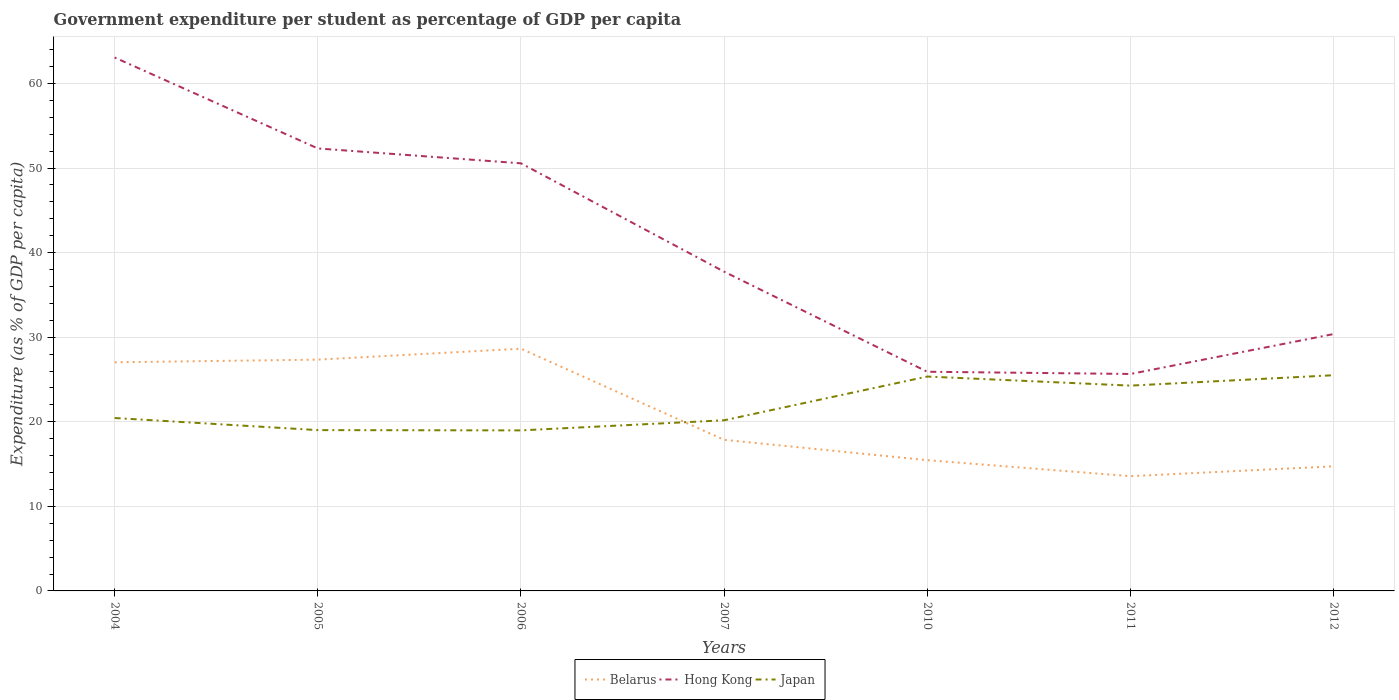Is the number of lines equal to the number of legend labels?
Your response must be concise. Yes. Across all years, what is the maximum percentage of expenditure per student in Japan?
Provide a succinct answer. 18.98. What is the total percentage of expenditure per student in Belarus in the graph?
Offer a terse response. -1.29. What is the difference between the highest and the second highest percentage of expenditure per student in Hong Kong?
Offer a terse response. 37.42. What is the difference between the highest and the lowest percentage of expenditure per student in Japan?
Provide a short and direct response. 3. How many lines are there?
Your response must be concise. 3. Are the values on the major ticks of Y-axis written in scientific E-notation?
Ensure brevity in your answer.  No. Does the graph contain grids?
Keep it short and to the point. Yes. Where does the legend appear in the graph?
Provide a succinct answer. Bottom center. How many legend labels are there?
Ensure brevity in your answer.  3. What is the title of the graph?
Offer a very short reply. Government expenditure per student as percentage of GDP per capita. Does "World" appear as one of the legend labels in the graph?
Offer a very short reply. No. What is the label or title of the X-axis?
Your answer should be compact. Years. What is the label or title of the Y-axis?
Ensure brevity in your answer.  Expenditure (as % of GDP per capita). What is the Expenditure (as % of GDP per capita) of Belarus in 2004?
Your answer should be very brief. 27.04. What is the Expenditure (as % of GDP per capita) in Hong Kong in 2004?
Offer a very short reply. 63.07. What is the Expenditure (as % of GDP per capita) in Japan in 2004?
Ensure brevity in your answer.  20.45. What is the Expenditure (as % of GDP per capita) of Belarus in 2005?
Offer a very short reply. 27.35. What is the Expenditure (as % of GDP per capita) in Hong Kong in 2005?
Ensure brevity in your answer.  52.32. What is the Expenditure (as % of GDP per capita) of Japan in 2005?
Offer a terse response. 19.02. What is the Expenditure (as % of GDP per capita) of Belarus in 2006?
Your answer should be compact. 28.64. What is the Expenditure (as % of GDP per capita) of Hong Kong in 2006?
Your response must be concise. 50.56. What is the Expenditure (as % of GDP per capita) of Japan in 2006?
Provide a succinct answer. 18.98. What is the Expenditure (as % of GDP per capita) in Belarus in 2007?
Give a very brief answer. 17.87. What is the Expenditure (as % of GDP per capita) of Hong Kong in 2007?
Give a very brief answer. 37.75. What is the Expenditure (as % of GDP per capita) in Japan in 2007?
Your response must be concise. 20.18. What is the Expenditure (as % of GDP per capita) in Belarus in 2010?
Provide a succinct answer. 15.46. What is the Expenditure (as % of GDP per capita) in Hong Kong in 2010?
Ensure brevity in your answer.  25.92. What is the Expenditure (as % of GDP per capita) in Japan in 2010?
Make the answer very short. 25.35. What is the Expenditure (as % of GDP per capita) of Belarus in 2011?
Offer a very short reply. 13.57. What is the Expenditure (as % of GDP per capita) of Hong Kong in 2011?
Give a very brief answer. 25.65. What is the Expenditure (as % of GDP per capita) in Japan in 2011?
Offer a very short reply. 24.28. What is the Expenditure (as % of GDP per capita) in Belarus in 2012?
Your answer should be very brief. 14.73. What is the Expenditure (as % of GDP per capita) in Hong Kong in 2012?
Your answer should be very brief. 30.37. What is the Expenditure (as % of GDP per capita) of Japan in 2012?
Give a very brief answer. 25.5. Across all years, what is the maximum Expenditure (as % of GDP per capita) of Belarus?
Provide a short and direct response. 28.64. Across all years, what is the maximum Expenditure (as % of GDP per capita) in Hong Kong?
Your answer should be very brief. 63.07. Across all years, what is the maximum Expenditure (as % of GDP per capita) in Japan?
Give a very brief answer. 25.5. Across all years, what is the minimum Expenditure (as % of GDP per capita) of Belarus?
Give a very brief answer. 13.57. Across all years, what is the minimum Expenditure (as % of GDP per capita) of Hong Kong?
Offer a very short reply. 25.65. Across all years, what is the minimum Expenditure (as % of GDP per capita) in Japan?
Keep it short and to the point. 18.98. What is the total Expenditure (as % of GDP per capita) of Belarus in the graph?
Your answer should be compact. 144.66. What is the total Expenditure (as % of GDP per capita) in Hong Kong in the graph?
Your answer should be very brief. 285.65. What is the total Expenditure (as % of GDP per capita) of Japan in the graph?
Offer a very short reply. 153.75. What is the difference between the Expenditure (as % of GDP per capita) in Belarus in 2004 and that in 2005?
Make the answer very short. -0.31. What is the difference between the Expenditure (as % of GDP per capita) of Hong Kong in 2004 and that in 2005?
Offer a terse response. 10.75. What is the difference between the Expenditure (as % of GDP per capita) of Japan in 2004 and that in 2005?
Ensure brevity in your answer.  1.43. What is the difference between the Expenditure (as % of GDP per capita) of Belarus in 2004 and that in 2006?
Offer a very short reply. -1.61. What is the difference between the Expenditure (as % of GDP per capita) of Hong Kong in 2004 and that in 2006?
Your answer should be very brief. 12.51. What is the difference between the Expenditure (as % of GDP per capita) in Japan in 2004 and that in 2006?
Provide a short and direct response. 1.47. What is the difference between the Expenditure (as % of GDP per capita) in Belarus in 2004 and that in 2007?
Give a very brief answer. 9.17. What is the difference between the Expenditure (as % of GDP per capita) in Hong Kong in 2004 and that in 2007?
Make the answer very short. 25.32. What is the difference between the Expenditure (as % of GDP per capita) in Japan in 2004 and that in 2007?
Offer a terse response. 0.27. What is the difference between the Expenditure (as % of GDP per capita) of Belarus in 2004 and that in 2010?
Your answer should be compact. 11.57. What is the difference between the Expenditure (as % of GDP per capita) in Hong Kong in 2004 and that in 2010?
Offer a terse response. 37.16. What is the difference between the Expenditure (as % of GDP per capita) of Japan in 2004 and that in 2010?
Provide a succinct answer. -4.9. What is the difference between the Expenditure (as % of GDP per capita) of Belarus in 2004 and that in 2011?
Offer a very short reply. 13.47. What is the difference between the Expenditure (as % of GDP per capita) of Hong Kong in 2004 and that in 2011?
Your answer should be compact. 37.42. What is the difference between the Expenditure (as % of GDP per capita) of Japan in 2004 and that in 2011?
Offer a very short reply. -3.83. What is the difference between the Expenditure (as % of GDP per capita) of Belarus in 2004 and that in 2012?
Provide a short and direct response. 12.3. What is the difference between the Expenditure (as % of GDP per capita) in Hong Kong in 2004 and that in 2012?
Your answer should be compact. 32.7. What is the difference between the Expenditure (as % of GDP per capita) of Japan in 2004 and that in 2012?
Ensure brevity in your answer.  -5.06. What is the difference between the Expenditure (as % of GDP per capita) in Belarus in 2005 and that in 2006?
Make the answer very short. -1.29. What is the difference between the Expenditure (as % of GDP per capita) in Hong Kong in 2005 and that in 2006?
Ensure brevity in your answer.  1.76. What is the difference between the Expenditure (as % of GDP per capita) in Japan in 2005 and that in 2006?
Give a very brief answer. 0.03. What is the difference between the Expenditure (as % of GDP per capita) in Belarus in 2005 and that in 2007?
Your answer should be very brief. 9.48. What is the difference between the Expenditure (as % of GDP per capita) in Hong Kong in 2005 and that in 2007?
Give a very brief answer. 14.57. What is the difference between the Expenditure (as % of GDP per capita) of Japan in 2005 and that in 2007?
Keep it short and to the point. -1.16. What is the difference between the Expenditure (as % of GDP per capita) in Belarus in 2005 and that in 2010?
Your answer should be very brief. 11.89. What is the difference between the Expenditure (as % of GDP per capita) in Hong Kong in 2005 and that in 2010?
Ensure brevity in your answer.  26.4. What is the difference between the Expenditure (as % of GDP per capita) of Japan in 2005 and that in 2010?
Your response must be concise. -6.34. What is the difference between the Expenditure (as % of GDP per capita) of Belarus in 2005 and that in 2011?
Your answer should be compact. 13.78. What is the difference between the Expenditure (as % of GDP per capita) of Hong Kong in 2005 and that in 2011?
Your response must be concise. 26.67. What is the difference between the Expenditure (as % of GDP per capita) in Japan in 2005 and that in 2011?
Offer a very short reply. -5.26. What is the difference between the Expenditure (as % of GDP per capita) in Belarus in 2005 and that in 2012?
Provide a succinct answer. 12.62. What is the difference between the Expenditure (as % of GDP per capita) in Hong Kong in 2005 and that in 2012?
Make the answer very short. 21.95. What is the difference between the Expenditure (as % of GDP per capita) in Japan in 2005 and that in 2012?
Ensure brevity in your answer.  -6.49. What is the difference between the Expenditure (as % of GDP per capita) of Belarus in 2006 and that in 2007?
Ensure brevity in your answer.  10.78. What is the difference between the Expenditure (as % of GDP per capita) in Hong Kong in 2006 and that in 2007?
Make the answer very short. 12.81. What is the difference between the Expenditure (as % of GDP per capita) of Japan in 2006 and that in 2007?
Provide a short and direct response. -1.19. What is the difference between the Expenditure (as % of GDP per capita) in Belarus in 2006 and that in 2010?
Offer a terse response. 13.18. What is the difference between the Expenditure (as % of GDP per capita) of Hong Kong in 2006 and that in 2010?
Keep it short and to the point. 24.65. What is the difference between the Expenditure (as % of GDP per capita) in Japan in 2006 and that in 2010?
Make the answer very short. -6.37. What is the difference between the Expenditure (as % of GDP per capita) of Belarus in 2006 and that in 2011?
Make the answer very short. 15.07. What is the difference between the Expenditure (as % of GDP per capita) in Hong Kong in 2006 and that in 2011?
Provide a succinct answer. 24.91. What is the difference between the Expenditure (as % of GDP per capita) of Japan in 2006 and that in 2011?
Offer a very short reply. -5.29. What is the difference between the Expenditure (as % of GDP per capita) in Belarus in 2006 and that in 2012?
Your answer should be very brief. 13.91. What is the difference between the Expenditure (as % of GDP per capita) of Hong Kong in 2006 and that in 2012?
Keep it short and to the point. 20.19. What is the difference between the Expenditure (as % of GDP per capita) of Japan in 2006 and that in 2012?
Give a very brief answer. -6.52. What is the difference between the Expenditure (as % of GDP per capita) of Belarus in 2007 and that in 2010?
Your response must be concise. 2.41. What is the difference between the Expenditure (as % of GDP per capita) of Hong Kong in 2007 and that in 2010?
Your answer should be compact. 11.83. What is the difference between the Expenditure (as % of GDP per capita) in Japan in 2007 and that in 2010?
Ensure brevity in your answer.  -5.17. What is the difference between the Expenditure (as % of GDP per capita) of Belarus in 2007 and that in 2011?
Give a very brief answer. 4.3. What is the difference between the Expenditure (as % of GDP per capita) of Hong Kong in 2007 and that in 2011?
Offer a very short reply. 12.1. What is the difference between the Expenditure (as % of GDP per capita) of Japan in 2007 and that in 2011?
Your answer should be very brief. -4.1. What is the difference between the Expenditure (as % of GDP per capita) of Belarus in 2007 and that in 2012?
Offer a terse response. 3.13. What is the difference between the Expenditure (as % of GDP per capita) of Hong Kong in 2007 and that in 2012?
Offer a very short reply. 7.38. What is the difference between the Expenditure (as % of GDP per capita) in Japan in 2007 and that in 2012?
Provide a short and direct response. -5.33. What is the difference between the Expenditure (as % of GDP per capita) in Belarus in 2010 and that in 2011?
Provide a succinct answer. 1.89. What is the difference between the Expenditure (as % of GDP per capita) in Hong Kong in 2010 and that in 2011?
Keep it short and to the point. 0.26. What is the difference between the Expenditure (as % of GDP per capita) in Japan in 2010 and that in 2011?
Give a very brief answer. 1.07. What is the difference between the Expenditure (as % of GDP per capita) in Belarus in 2010 and that in 2012?
Provide a short and direct response. 0.73. What is the difference between the Expenditure (as % of GDP per capita) of Hong Kong in 2010 and that in 2012?
Your answer should be compact. -4.46. What is the difference between the Expenditure (as % of GDP per capita) in Japan in 2010 and that in 2012?
Your answer should be very brief. -0.15. What is the difference between the Expenditure (as % of GDP per capita) in Belarus in 2011 and that in 2012?
Provide a succinct answer. -1.16. What is the difference between the Expenditure (as % of GDP per capita) of Hong Kong in 2011 and that in 2012?
Offer a terse response. -4.72. What is the difference between the Expenditure (as % of GDP per capita) of Japan in 2011 and that in 2012?
Ensure brevity in your answer.  -1.23. What is the difference between the Expenditure (as % of GDP per capita) of Belarus in 2004 and the Expenditure (as % of GDP per capita) of Hong Kong in 2005?
Provide a succinct answer. -25.29. What is the difference between the Expenditure (as % of GDP per capita) of Belarus in 2004 and the Expenditure (as % of GDP per capita) of Japan in 2005?
Keep it short and to the point. 8.02. What is the difference between the Expenditure (as % of GDP per capita) in Hong Kong in 2004 and the Expenditure (as % of GDP per capita) in Japan in 2005?
Your answer should be very brief. 44.06. What is the difference between the Expenditure (as % of GDP per capita) in Belarus in 2004 and the Expenditure (as % of GDP per capita) in Hong Kong in 2006?
Your answer should be compact. -23.53. What is the difference between the Expenditure (as % of GDP per capita) in Belarus in 2004 and the Expenditure (as % of GDP per capita) in Japan in 2006?
Keep it short and to the point. 8.05. What is the difference between the Expenditure (as % of GDP per capita) in Hong Kong in 2004 and the Expenditure (as % of GDP per capita) in Japan in 2006?
Provide a succinct answer. 44.09. What is the difference between the Expenditure (as % of GDP per capita) in Belarus in 2004 and the Expenditure (as % of GDP per capita) in Hong Kong in 2007?
Your answer should be very brief. -10.72. What is the difference between the Expenditure (as % of GDP per capita) in Belarus in 2004 and the Expenditure (as % of GDP per capita) in Japan in 2007?
Ensure brevity in your answer.  6.86. What is the difference between the Expenditure (as % of GDP per capita) in Hong Kong in 2004 and the Expenditure (as % of GDP per capita) in Japan in 2007?
Your response must be concise. 42.9. What is the difference between the Expenditure (as % of GDP per capita) in Belarus in 2004 and the Expenditure (as % of GDP per capita) in Hong Kong in 2010?
Offer a terse response. 1.12. What is the difference between the Expenditure (as % of GDP per capita) of Belarus in 2004 and the Expenditure (as % of GDP per capita) of Japan in 2010?
Provide a succinct answer. 1.68. What is the difference between the Expenditure (as % of GDP per capita) of Hong Kong in 2004 and the Expenditure (as % of GDP per capita) of Japan in 2010?
Offer a terse response. 37.72. What is the difference between the Expenditure (as % of GDP per capita) in Belarus in 2004 and the Expenditure (as % of GDP per capita) in Hong Kong in 2011?
Offer a terse response. 1.38. What is the difference between the Expenditure (as % of GDP per capita) of Belarus in 2004 and the Expenditure (as % of GDP per capita) of Japan in 2011?
Keep it short and to the point. 2.76. What is the difference between the Expenditure (as % of GDP per capita) in Hong Kong in 2004 and the Expenditure (as % of GDP per capita) in Japan in 2011?
Ensure brevity in your answer.  38.8. What is the difference between the Expenditure (as % of GDP per capita) of Belarus in 2004 and the Expenditure (as % of GDP per capita) of Hong Kong in 2012?
Provide a short and direct response. -3.34. What is the difference between the Expenditure (as % of GDP per capita) of Belarus in 2004 and the Expenditure (as % of GDP per capita) of Japan in 2012?
Ensure brevity in your answer.  1.53. What is the difference between the Expenditure (as % of GDP per capita) of Hong Kong in 2004 and the Expenditure (as % of GDP per capita) of Japan in 2012?
Give a very brief answer. 37.57. What is the difference between the Expenditure (as % of GDP per capita) in Belarus in 2005 and the Expenditure (as % of GDP per capita) in Hong Kong in 2006?
Provide a succinct answer. -23.21. What is the difference between the Expenditure (as % of GDP per capita) of Belarus in 2005 and the Expenditure (as % of GDP per capita) of Japan in 2006?
Keep it short and to the point. 8.37. What is the difference between the Expenditure (as % of GDP per capita) of Hong Kong in 2005 and the Expenditure (as % of GDP per capita) of Japan in 2006?
Offer a very short reply. 33.34. What is the difference between the Expenditure (as % of GDP per capita) of Belarus in 2005 and the Expenditure (as % of GDP per capita) of Hong Kong in 2007?
Your answer should be compact. -10.4. What is the difference between the Expenditure (as % of GDP per capita) in Belarus in 2005 and the Expenditure (as % of GDP per capita) in Japan in 2007?
Offer a terse response. 7.17. What is the difference between the Expenditure (as % of GDP per capita) of Hong Kong in 2005 and the Expenditure (as % of GDP per capita) of Japan in 2007?
Your answer should be compact. 32.15. What is the difference between the Expenditure (as % of GDP per capita) in Belarus in 2005 and the Expenditure (as % of GDP per capita) in Hong Kong in 2010?
Provide a short and direct response. 1.43. What is the difference between the Expenditure (as % of GDP per capita) of Belarus in 2005 and the Expenditure (as % of GDP per capita) of Japan in 2010?
Offer a terse response. 2. What is the difference between the Expenditure (as % of GDP per capita) in Hong Kong in 2005 and the Expenditure (as % of GDP per capita) in Japan in 2010?
Give a very brief answer. 26.97. What is the difference between the Expenditure (as % of GDP per capita) in Belarus in 2005 and the Expenditure (as % of GDP per capita) in Hong Kong in 2011?
Offer a terse response. 1.69. What is the difference between the Expenditure (as % of GDP per capita) in Belarus in 2005 and the Expenditure (as % of GDP per capita) in Japan in 2011?
Provide a succinct answer. 3.07. What is the difference between the Expenditure (as % of GDP per capita) of Hong Kong in 2005 and the Expenditure (as % of GDP per capita) of Japan in 2011?
Keep it short and to the point. 28.05. What is the difference between the Expenditure (as % of GDP per capita) of Belarus in 2005 and the Expenditure (as % of GDP per capita) of Hong Kong in 2012?
Your answer should be compact. -3.02. What is the difference between the Expenditure (as % of GDP per capita) of Belarus in 2005 and the Expenditure (as % of GDP per capita) of Japan in 2012?
Your answer should be very brief. 1.84. What is the difference between the Expenditure (as % of GDP per capita) in Hong Kong in 2005 and the Expenditure (as % of GDP per capita) in Japan in 2012?
Offer a terse response. 26.82. What is the difference between the Expenditure (as % of GDP per capita) of Belarus in 2006 and the Expenditure (as % of GDP per capita) of Hong Kong in 2007?
Give a very brief answer. -9.11. What is the difference between the Expenditure (as % of GDP per capita) of Belarus in 2006 and the Expenditure (as % of GDP per capita) of Japan in 2007?
Ensure brevity in your answer.  8.47. What is the difference between the Expenditure (as % of GDP per capita) in Hong Kong in 2006 and the Expenditure (as % of GDP per capita) in Japan in 2007?
Give a very brief answer. 30.39. What is the difference between the Expenditure (as % of GDP per capita) of Belarus in 2006 and the Expenditure (as % of GDP per capita) of Hong Kong in 2010?
Offer a very short reply. 2.73. What is the difference between the Expenditure (as % of GDP per capita) in Belarus in 2006 and the Expenditure (as % of GDP per capita) in Japan in 2010?
Offer a terse response. 3.29. What is the difference between the Expenditure (as % of GDP per capita) of Hong Kong in 2006 and the Expenditure (as % of GDP per capita) of Japan in 2010?
Make the answer very short. 25.21. What is the difference between the Expenditure (as % of GDP per capita) in Belarus in 2006 and the Expenditure (as % of GDP per capita) in Hong Kong in 2011?
Provide a succinct answer. 2.99. What is the difference between the Expenditure (as % of GDP per capita) in Belarus in 2006 and the Expenditure (as % of GDP per capita) in Japan in 2011?
Offer a terse response. 4.37. What is the difference between the Expenditure (as % of GDP per capita) in Hong Kong in 2006 and the Expenditure (as % of GDP per capita) in Japan in 2011?
Ensure brevity in your answer.  26.29. What is the difference between the Expenditure (as % of GDP per capita) in Belarus in 2006 and the Expenditure (as % of GDP per capita) in Hong Kong in 2012?
Your answer should be compact. -1.73. What is the difference between the Expenditure (as % of GDP per capita) in Belarus in 2006 and the Expenditure (as % of GDP per capita) in Japan in 2012?
Provide a succinct answer. 3.14. What is the difference between the Expenditure (as % of GDP per capita) in Hong Kong in 2006 and the Expenditure (as % of GDP per capita) in Japan in 2012?
Ensure brevity in your answer.  25.06. What is the difference between the Expenditure (as % of GDP per capita) of Belarus in 2007 and the Expenditure (as % of GDP per capita) of Hong Kong in 2010?
Your answer should be very brief. -8.05. What is the difference between the Expenditure (as % of GDP per capita) in Belarus in 2007 and the Expenditure (as % of GDP per capita) in Japan in 2010?
Offer a very short reply. -7.48. What is the difference between the Expenditure (as % of GDP per capita) of Hong Kong in 2007 and the Expenditure (as % of GDP per capita) of Japan in 2010?
Ensure brevity in your answer.  12.4. What is the difference between the Expenditure (as % of GDP per capita) of Belarus in 2007 and the Expenditure (as % of GDP per capita) of Hong Kong in 2011?
Make the answer very short. -7.79. What is the difference between the Expenditure (as % of GDP per capita) in Belarus in 2007 and the Expenditure (as % of GDP per capita) in Japan in 2011?
Give a very brief answer. -6.41. What is the difference between the Expenditure (as % of GDP per capita) in Hong Kong in 2007 and the Expenditure (as % of GDP per capita) in Japan in 2011?
Provide a succinct answer. 13.47. What is the difference between the Expenditure (as % of GDP per capita) in Belarus in 2007 and the Expenditure (as % of GDP per capita) in Hong Kong in 2012?
Ensure brevity in your answer.  -12.5. What is the difference between the Expenditure (as % of GDP per capita) of Belarus in 2007 and the Expenditure (as % of GDP per capita) of Japan in 2012?
Provide a succinct answer. -7.64. What is the difference between the Expenditure (as % of GDP per capita) of Hong Kong in 2007 and the Expenditure (as % of GDP per capita) of Japan in 2012?
Your response must be concise. 12.25. What is the difference between the Expenditure (as % of GDP per capita) of Belarus in 2010 and the Expenditure (as % of GDP per capita) of Hong Kong in 2011?
Ensure brevity in your answer.  -10.19. What is the difference between the Expenditure (as % of GDP per capita) of Belarus in 2010 and the Expenditure (as % of GDP per capita) of Japan in 2011?
Your answer should be compact. -8.82. What is the difference between the Expenditure (as % of GDP per capita) in Hong Kong in 2010 and the Expenditure (as % of GDP per capita) in Japan in 2011?
Give a very brief answer. 1.64. What is the difference between the Expenditure (as % of GDP per capita) of Belarus in 2010 and the Expenditure (as % of GDP per capita) of Hong Kong in 2012?
Provide a succinct answer. -14.91. What is the difference between the Expenditure (as % of GDP per capita) of Belarus in 2010 and the Expenditure (as % of GDP per capita) of Japan in 2012?
Keep it short and to the point. -10.04. What is the difference between the Expenditure (as % of GDP per capita) in Hong Kong in 2010 and the Expenditure (as % of GDP per capita) in Japan in 2012?
Make the answer very short. 0.41. What is the difference between the Expenditure (as % of GDP per capita) in Belarus in 2011 and the Expenditure (as % of GDP per capita) in Hong Kong in 2012?
Your answer should be compact. -16.8. What is the difference between the Expenditure (as % of GDP per capita) in Belarus in 2011 and the Expenditure (as % of GDP per capita) in Japan in 2012?
Provide a succinct answer. -11.94. What is the difference between the Expenditure (as % of GDP per capita) of Hong Kong in 2011 and the Expenditure (as % of GDP per capita) of Japan in 2012?
Offer a very short reply. 0.15. What is the average Expenditure (as % of GDP per capita) in Belarus per year?
Your answer should be very brief. 20.67. What is the average Expenditure (as % of GDP per capita) of Hong Kong per year?
Give a very brief answer. 40.81. What is the average Expenditure (as % of GDP per capita) of Japan per year?
Your answer should be very brief. 21.96. In the year 2004, what is the difference between the Expenditure (as % of GDP per capita) of Belarus and Expenditure (as % of GDP per capita) of Hong Kong?
Your answer should be compact. -36.04. In the year 2004, what is the difference between the Expenditure (as % of GDP per capita) in Belarus and Expenditure (as % of GDP per capita) in Japan?
Make the answer very short. 6.59. In the year 2004, what is the difference between the Expenditure (as % of GDP per capita) in Hong Kong and Expenditure (as % of GDP per capita) in Japan?
Ensure brevity in your answer.  42.63. In the year 2005, what is the difference between the Expenditure (as % of GDP per capita) in Belarus and Expenditure (as % of GDP per capita) in Hong Kong?
Give a very brief answer. -24.97. In the year 2005, what is the difference between the Expenditure (as % of GDP per capita) of Belarus and Expenditure (as % of GDP per capita) of Japan?
Offer a very short reply. 8.33. In the year 2005, what is the difference between the Expenditure (as % of GDP per capita) in Hong Kong and Expenditure (as % of GDP per capita) in Japan?
Your response must be concise. 33.31. In the year 2006, what is the difference between the Expenditure (as % of GDP per capita) in Belarus and Expenditure (as % of GDP per capita) in Hong Kong?
Offer a terse response. -21.92. In the year 2006, what is the difference between the Expenditure (as % of GDP per capita) of Belarus and Expenditure (as % of GDP per capita) of Japan?
Make the answer very short. 9.66. In the year 2006, what is the difference between the Expenditure (as % of GDP per capita) of Hong Kong and Expenditure (as % of GDP per capita) of Japan?
Your answer should be compact. 31.58. In the year 2007, what is the difference between the Expenditure (as % of GDP per capita) of Belarus and Expenditure (as % of GDP per capita) of Hong Kong?
Keep it short and to the point. -19.88. In the year 2007, what is the difference between the Expenditure (as % of GDP per capita) of Belarus and Expenditure (as % of GDP per capita) of Japan?
Make the answer very short. -2.31. In the year 2007, what is the difference between the Expenditure (as % of GDP per capita) of Hong Kong and Expenditure (as % of GDP per capita) of Japan?
Give a very brief answer. 17.57. In the year 2010, what is the difference between the Expenditure (as % of GDP per capita) of Belarus and Expenditure (as % of GDP per capita) of Hong Kong?
Make the answer very short. -10.46. In the year 2010, what is the difference between the Expenditure (as % of GDP per capita) in Belarus and Expenditure (as % of GDP per capita) in Japan?
Ensure brevity in your answer.  -9.89. In the year 2010, what is the difference between the Expenditure (as % of GDP per capita) of Hong Kong and Expenditure (as % of GDP per capita) of Japan?
Provide a succinct answer. 0.57. In the year 2011, what is the difference between the Expenditure (as % of GDP per capita) in Belarus and Expenditure (as % of GDP per capita) in Hong Kong?
Provide a succinct answer. -12.08. In the year 2011, what is the difference between the Expenditure (as % of GDP per capita) in Belarus and Expenditure (as % of GDP per capita) in Japan?
Offer a very short reply. -10.71. In the year 2011, what is the difference between the Expenditure (as % of GDP per capita) of Hong Kong and Expenditure (as % of GDP per capita) of Japan?
Ensure brevity in your answer.  1.38. In the year 2012, what is the difference between the Expenditure (as % of GDP per capita) in Belarus and Expenditure (as % of GDP per capita) in Hong Kong?
Offer a terse response. -15.64. In the year 2012, what is the difference between the Expenditure (as % of GDP per capita) in Belarus and Expenditure (as % of GDP per capita) in Japan?
Your response must be concise. -10.77. In the year 2012, what is the difference between the Expenditure (as % of GDP per capita) in Hong Kong and Expenditure (as % of GDP per capita) in Japan?
Provide a short and direct response. 4.87. What is the ratio of the Expenditure (as % of GDP per capita) in Belarus in 2004 to that in 2005?
Offer a very short reply. 0.99. What is the ratio of the Expenditure (as % of GDP per capita) in Hong Kong in 2004 to that in 2005?
Provide a succinct answer. 1.21. What is the ratio of the Expenditure (as % of GDP per capita) in Japan in 2004 to that in 2005?
Your answer should be compact. 1.08. What is the ratio of the Expenditure (as % of GDP per capita) in Belarus in 2004 to that in 2006?
Give a very brief answer. 0.94. What is the ratio of the Expenditure (as % of GDP per capita) in Hong Kong in 2004 to that in 2006?
Offer a terse response. 1.25. What is the ratio of the Expenditure (as % of GDP per capita) in Japan in 2004 to that in 2006?
Make the answer very short. 1.08. What is the ratio of the Expenditure (as % of GDP per capita) in Belarus in 2004 to that in 2007?
Offer a terse response. 1.51. What is the ratio of the Expenditure (as % of GDP per capita) of Hong Kong in 2004 to that in 2007?
Make the answer very short. 1.67. What is the ratio of the Expenditure (as % of GDP per capita) of Japan in 2004 to that in 2007?
Offer a terse response. 1.01. What is the ratio of the Expenditure (as % of GDP per capita) in Belarus in 2004 to that in 2010?
Offer a very short reply. 1.75. What is the ratio of the Expenditure (as % of GDP per capita) in Hong Kong in 2004 to that in 2010?
Give a very brief answer. 2.43. What is the ratio of the Expenditure (as % of GDP per capita) in Japan in 2004 to that in 2010?
Ensure brevity in your answer.  0.81. What is the ratio of the Expenditure (as % of GDP per capita) in Belarus in 2004 to that in 2011?
Provide a short and direct response. 1.99. What is the ratio of the Expenditure (as % of GDP per capita) of Hong Kong in 2004 to that in 2011?
Give a very brief answer. 2.46. What is the ratio of the Expenditure (as % of GDP per capita) in Japan in 2004 to that in 2011?
Provide a short and direct response. 0.84. What is the ratio of the Expenditure (as % of GDP per capita) of Belarus in 2004 to that in 2012?
Give a very brief answer. 1.83. What is the ratio of the Expenditure (as % of GDP per capita) in Hong Kong in 2004 to that in 2012?
Your answer should be compact. 2.08. What is the ratio of the Expenditure (as % of GDP per capita) of Japan in 2004 to that in 2012?
Offer a terse response. 0.8. What is the ratio of the Expenditure (as % of GDP per capita) in Belarus in 2005 to that in 2006?
Ensure brevity in your answer.  0.95. What is the ratio of the Expenditure (as % of GDP per capita) of Hong Kong in 2005 to that in 2006?
Offer a very short reply. 1.03. What is the ratio of the Expenditure (as % of GDP per capita) in Japan in 2005 to that in 2006?
Ensure brevity in your answer.  1. What is the ratio of the Expenditure (as % of GDP per capita) in Belarus in 2005 to that in 2007?
Your response must be concise. 1.53. What is the ratio of the Expenditure (as % of GDP per capita) of Hong Kong in 2005 to that in 2007?
Make the answer very short. 1.39. What is the ratio of the Expenditure (as % of GDP per capita) of Japan in 2005 to that in 2007?
Your answer should be compact. 0.94. What is the ratio of the Expenditure (as % of GDP per capita) in Belarus in 2005 to that in 2010?
Provide a short and direct response. 1.77. What is the ratio of the Expenditure (as % of GDP per capita) in Hong Kong in 2005 to that in 2010?
Offer a terse response. 2.02. What is the ratio of the Expenditure (as % of GDP per capita) in Japan in 2005 to that in 2010?
Keep it short and to the point. 0.75. What is the ratio of the Expenditure (as % of GDP per capita) in Belarus in 2005 to that in 2011?
Your answer should be very brief. 2.02. What is the ratio of the Expenditure (as % of GDP per capita) in Hong Kong in 2005 to that in 2011?
Keep it short and to the point. 2.04. What is the ratio of the Expenditure (as % of GDP per capita) in Japan in 2005 to that in 2011?
Offer a terse response. 0.78. What is the ratio of the Expenditure (as % of GDP per capita) in Belarus in 2005 to that in 2012?
Provide a succinct answer. 1.86. What is the ratio of the Expenditure (as % of GDP per capita) of Hong Kong in 2005 to that in 2012?
Keep it short and to the point. 1.72. What is the ratio of the Expenditure (as % of GDP per capita) of Japan in 2005 to that in 2012?
Ensure brevity in your answer.  0.75. What is the ratio of the Expenditure (as % of GDP per capita) of Belarus in 2006 to that in 2007?
Give a very brief answer. 1.6. What is the ratio of the Expenditure (as % of GDP per capita) of Hong Kong in 2006 to that in 2007?
Give a very brief answer. 1.34. What is the ratio of the Expenditure (as % of GDP per capita) of Japan in 2006 to that in 2007?
Offer a terse response. 0.94. What is the ratio of the Expenditure (as % of GDP per capita) in Belarus in 2006 to that in 2010?
Provide a succinct answer. 1.85. What is the ratio of the Expenditure (as % of GDP per capita) of Hong Kong in 2006 to that in 2010?
Keep it short and to the point. 1.95. What is the ratio of the Expenditure (as % of GDP per capita) of Japan in 2006 to that in 2010?
Make the answer very short. 0.75. What is the ratio of the Expenditure (as % of GDP per capita) of Belarus in 2006 to that in 2011?
Provide a short and direct response. 2.11. What is the ratio of the Expenditure (as % of GDP per capita) of Hong Kong in 2006 to that in 2011?
Ensure brevity in your answer.  1.97. What is the ratio of the Expenditure (as % of GDP per capita) in Japan in 2006 to that in 2011?
Make the answer very short. 0.78. What is the ratio of the Expenditure (as % of GDP per capita) of Belarus in 2006 to that in 2012?
Offer a very short reply. 1.94. What is the ratio of the Expenditure (as % of GDP per capita) of Hong Kong in 2006 to that in 2012?
Keep it short and to the point. 1.66. What is the ratio of the Expenditure (as % of GDP per capita) in Japan in 2006 to that in 2012?
Keep it short and to the point. 0.74. What is the ratio of the Expenditure (as % of GDP per capita) in Belarus in 2007 to that in 2010?
Ensure brevity in your answer.  1.16. What is the ratio of the Expenditure (as % of GDP per capita) in Hong Kong in 2007 to that in 2010?
Your response must be concise. 1.46. What is the ratio of the Expenditure (as % of GDP per capita) of Japan in 2007 to that in 2010?
Your answer should be very brief. 0.8. What is the ratio of the Expenditure (as % of GDP per capita) of Belarus in 2007 to that in 2011?
Your answer should be very brief. 1.32. What is the ratio of the Expenditure (as % of GDP per capita) of Hong Kong in 2007 to that in 2011?
Ensure brevity in your answer.  1.47. What is the ratio of the Expenditure (as % of GDP per capita) of Japan in 2007 to that in 2011?
Your answer should be very brief. 0.83. What is the ratio of the Expenditure (as % of GDP per capita) in Belarus in 2007 to that in 2012?
Your response must be concise. 1.21. What is the ratio of the Expenditure (as % of GDP per capita) of Hong Kong in 2007 to that in 2012?
Your response must be concise. 1.24. What is the ratio of the Expenditure (as % of GDP per capita) of Japan in 2007 to that in 2012?
Make the answer very short. 0.79. What is the ratio of the Expenditure (as % of GDP per capita) of Belarus in 2010 to that in 2011?
Keep it short and to the point. 1.14. What is the ratio of the Expenditure (as % of GDP per capita) of Hong Kong in 2010 to that in 2011?
Ensure brevity in your answer.  1.01. What is the ratio of the Expenditure (as % of GDP per capita) of Japan in 2010 to that in 2011?
Offer a very short reply. 1.04. What is the ratio of the Expenditure (as % of GDP per capita) of Belarus in 2010 to that in 2012?
Your answer should be compact. 1.05. What is the ratio of the Expenditure (as % of GDP per capita) in Hong Kong in 2010 to that in 2012?
Provide a short and direct response. 0.85. What is the ratio of the Expenditure (as % of GDP per capita) in Japan in 2010 to that in 2012?
Ensure brevity in your answer.  0.99. What is the ratio of the Expenditure (as % of GDP per capita) of Belarus in 2011 to that in 2012?
Your response must be concise. 0.92. What is the ratio of the Expenditure (as % of GDP per capita) in Hong Kong in 2011 to that in 2012?
Keep it short and to the point. 0.84. What is the ratio of the Expenditure (as % of GDP per capita) of Japan in 2011 to that in 2012?
Keep it short and to the point. 0.95. What is the difference between the highest and the second highest Expenditure (as % of GDP per capita) of Belarus?
Provide a short and direct response. 1.29. What is the difference between the highest and the second highest Expenditure (as % of GDP per capita) of Hong Kong?
Give a very brief answer. 10.75. What is the difference between the highest and the second highest Expenditure (as % of GDP per capita) of Japan?
Make the answer very short. 0.15. What is the difference between the highest and the lowest Expenditure (as % of GDP per capita) of Belarus?
Provide a short and direct response. 15.07. What is the difference between the highest and the lowest Expenditure (as % of GDP per capita) in Hong Kong?
Give a very brief answer. 37.42. What is the difference between the highest and the lowest Expenditure (as % of GDP per capita) in Japan?
Offer a terse response. 6.52. 